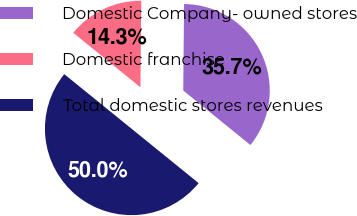<chart> <loc_0><loc_0><loc_500><loc_500><pie_chart><fcel>Domestic Company- owned stores<fcel>Domestic franchise<fcel>Total domestic stores revenues<nl><fcel>35.69%<fcel>14.31%<fcel>50.0%<nl></chart> 